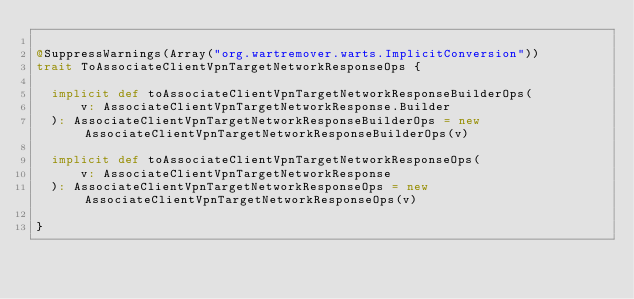<code> <loc_0><loc_0><loc_500><loc_500><_Scala_>
@SuppressWarnings(Array("org.wartremover.warts.ImplicitConversion"))
trait ToAssociateClientVpnTargetNetworkResponseOps {

  implicit def toAssociateClientVpnTargetNetworkResponseBuilderOps(
      v: AssociateClientVpnTargetNetworkResponse.Builder
  ): AssociateClientVpnTargetNetworkResponseBuilderOps = new AssociateClientVpnTargetNetworkResponseBuilderOps(v)

  implicit def toAssociateClientVpnTargetNetworkResponseOps(
      v: AssociateClientVpnTargetNetworkResponse
  ): AssociateClientVpnTargetNetworkResponseOps = new AssociateClientVpnTargetNetworkResponseOps(v)

}
</code> 